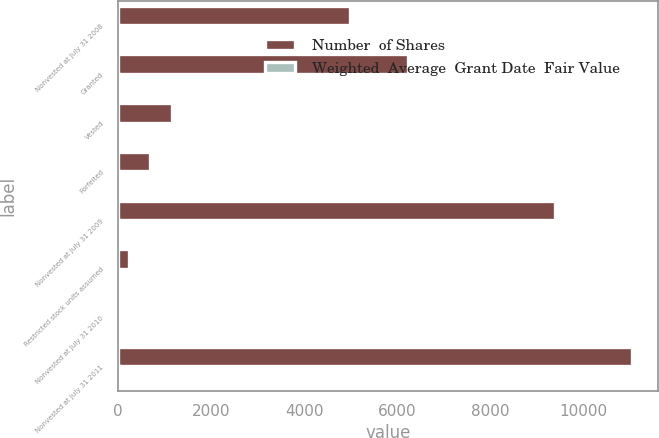Convert chart. <chart><loc_0><loc_0><loc_500><loc_500><stacked_bar_chart><ecel><fcel>Nonvested at July 31 2008<fcel>Granted<fcel>Vested<fcel>Forfeited<fcel>Nonvested at July 31 2009<fcel>Restricted stock units assumed<fcel>Nonvested at July 31 2010<fcel>Nonvested at July 31 2011<nl><fcel>Number  of Shares<fcel>4997<fcel>6242<fcel>1150<fcel>691<fcel>9398<fcel>231<fcel>37.92<fcel>11055<nl><fcel>Weighted  Average  Grant Date  Fair Value<fcel>29.29<fcel>26.09<fcel>30.54<fcel>28.53<fcel>27.06<fcel>29.14<fcel>30.93<fcel>37.92<nl></chart> 